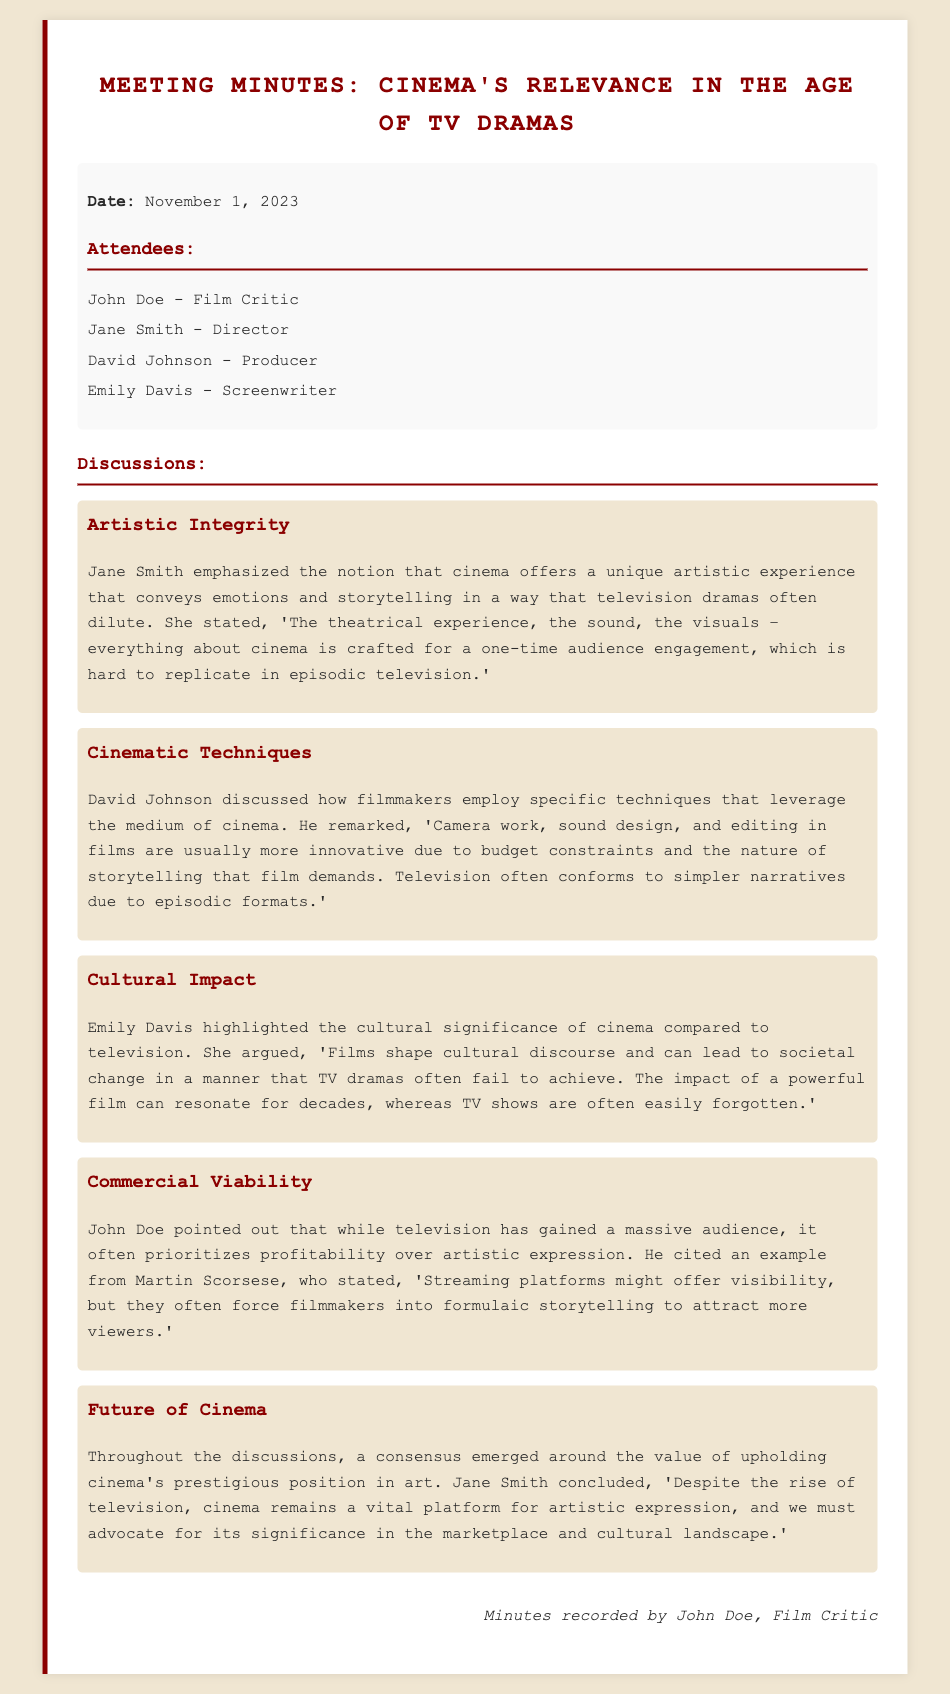what is the date of the meeting? The date of the meeting is mentioned at the beginning of the document.
Answer: November 1, 2023 who emphasized the notion of cinema's unique artistic experience? The document states that Jane Smith emphasized this notion during the discussions.
Answer: Jane Smith what specific cinematic technique did David Johnson mention? David Johnson talked about filming techniques such as camera work and sound design.
Answer: Camera work, sound design who argued about the cultural significance of cinema? The document indicates that Emily Davis highlighted cinema's cultural significance.
Answer: Emily Davis what was John Doe's view on commercial viability? John Doe pointed out that television often prioritizes profitability over artistic expression.
Answer: Profitability over artistic expression which filmmaker's perspective on streaming platforms was cited in the discussion? John Doe cited Martin Scorsese’s perspective in this context.
Answer: Martin Scorsese what conclusion did Jane Smith reach about the future of cinema? Jane Smith concluded that cinema remains a vital platform for artistic expression despite television's rise.
Answer: Vital platform for artistic expression how many attendees are listed in the meeting minutes? The document lists the names of four attendees participating in the meeting.
Answer: Four what color is used for the header of the meeting minutes? The header color used in the document is specified.
Answer: #8b0000 